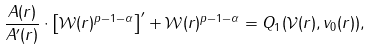Convert formula to latex. <formula><loc_0><loc_0><loc_500><loc_500>\frac { A ( r ) } { A ^ { \prime } ( r ) } \cdot \left [ \mathcal { W } ( r ) ^ { p - 1 - \alpha } \right ] ^ { \prime } + \mathcal { W } ( r ) ^ { p - 1 - \alpha } = Q _ { 1 } ( \mathcal { V } ( r ) , v _ { 0 } ( r ) ) ,</formula> 